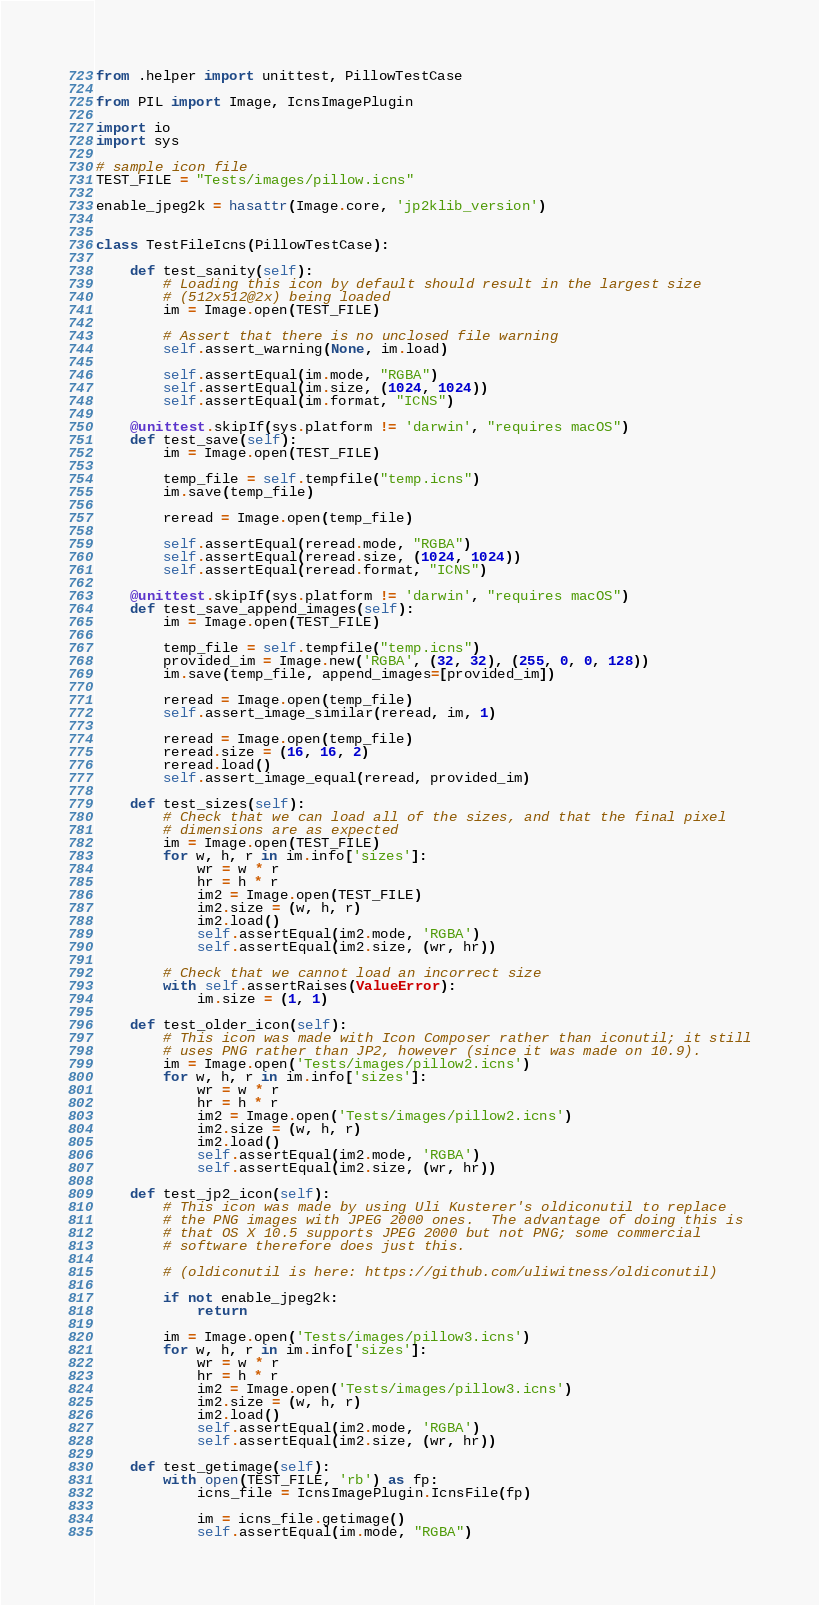<code> <loc_0><loc_0><loc_500><loc_500><_Python_>from .helper import unittest, PillowTestCase

from PIL import Image, IcnsImagePlugin

import io
import sys

# sample icon file
TEST_FILE = "Tests/images/pillow.icns"

enable_jpeg2k = hasattr(Image.core, 'jp2klib_version')


class TestFileIcns(PillowTestCase):

    def test_sanity(self):
        # Loading this icon by default should result in the largest size
        # (512x512@2x) being loaded
        im = Image.open(TEST_FILE)

        # Assert that there is no unclosed file warning
        self.assert_warning(None, im.load)

        self.assertEqual(im.mode, "RGBA")
        self.assertEqual(im.size, (1024, 1024))
        self.assertEqual(im.format, "ICNS")

    @unittest.skipIf(sys.platform != 'darwin', "requires macOS")
    def test_save(self):
        im = Image.open(TEST_FILE)

        temp_file = self.tempfile("temp.icns")
        im.save(temp_file)

        reread = Image.open(temp_file)

        self.assertEqual(reread.mode, "RGBA")
        self.assertEqual(reread.size, (1024, 1024))
        self.assertEqual(reread.format, "ICNS")

    @unittest.skipIf(sys.platform != 'darwin', "requires macOS")
    def test_save_append_images(self):
        im = Image.open(TEST_FILE)

        temp_file = self.tempfile("temp.icns")
        provided_im = Image.new('RGBA', (32, 32), (255, 0, 0, 128))
        im.save(temp_file, append_images=[provided_im])

        reread = Image.open(temp_file)
        self.assert_image_similar(reread, im, 1)

        reread = Image.open(temp_file)
        reread.size = (16, 16, 2)
        reread.load()
        self.assert_image_equal(reread, provided_im)

    def test_sizes(self):
        # Check that we can load all of the sizes, and that the final pixel
        # dimensions are as expected
        im = Image.open(TEST_FILE)
        for w, h, r in im.info['sizes']:
            wr = w * r
            hr = h * r
            im2 = Image.open(TEST_FILE)
            im2.size = (w, h, r)
            im2.load()
            self.assertEqual(im2.mode, 'RGBA')
            self.assertEqual(im2.size, (wr, hr))

        # Check that we cannot load an incorrect size
        with self.assertRaises(ValueError):
            im.size = (1, 1)

    def test_older_icon(self):
        # This icon was made with Icon Composer rather than iconutil; it still
        # uses PNG rather than JP2, however (since it was made on 10.9).
        im = Image.open('Tests/images/pillow2.icns')
        for w, h, r in im.info['sizes']:
            wr = w * r
            hr = h * r
            im2 = Image.open('Tests/images/pillow2.icns')
            im2.size = (w, h, r)
            im2.load()
            self.assertEqual(im2.mode, 'RGBA')
            self.assertEqual(im2.size, (wr, hr))

    def test_jp2_icon(self):
        # This icon was made by using Uli Kusterer's oldiconutil to replace
        # the PNG images with JPEG 2000 ones.  The advantage of doing this is
        # that OS X 10.5 supports JPEG 2000 but not PNG; some commercial
        # software therefore does just this.

        # (oldiconutil is here: https://github.com/uliwitness/oldiconutil)

        if not enable_jpeg2k:
            return

        im = Image.open('Tests/images/pillow3.icns')
        for w, h, r in im.info['sizes']:
            wr = w * r
            hr = h * r
            im2 = Image.open('Tests/images/pillow3.icns')
            im2.size = (w, h, r)
            im2.load()
            self.assertEqual(im2.mode, 'RGBA')
            self.assertEqual(im2.size, (wr, hr))

    def test_getimage(self):
        with open(TEST_FILE, 'rb') as fp:
            icns_file = IcnsImagePlugin.IcnsFile(fp)

            im = icns_file.getimage()
            self.assertEqual(im.mode, "RGBA")</code> 